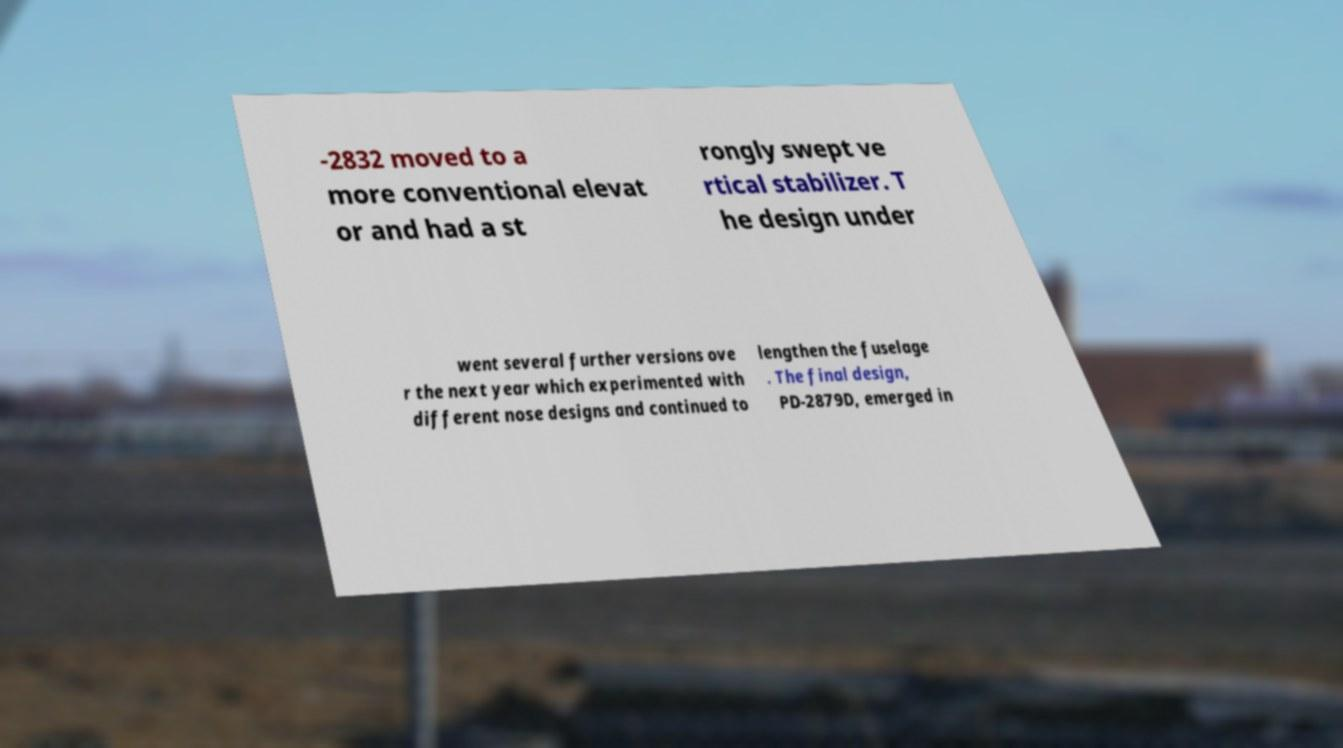Please identify and transcribe the text found in this image. -2832 moved to a more conventional elevat or and had a st rongly swept ve rtical stabilizer. T he design under went several further versions ove r the next year which experimented with different nose designs and continued to lengthen the fuselage . The final design, PD-2879D, emerged in 